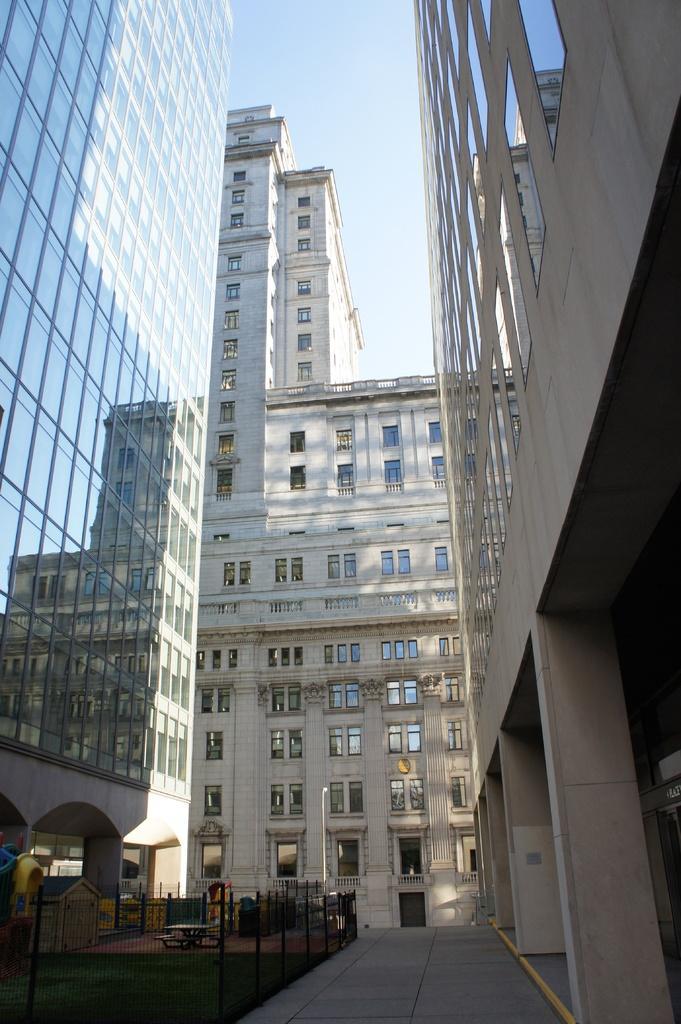Describe this image in one or two sentences. In this image I can see few buildings in white and cream color. I can also see the fencing, background the sky is in white color. 